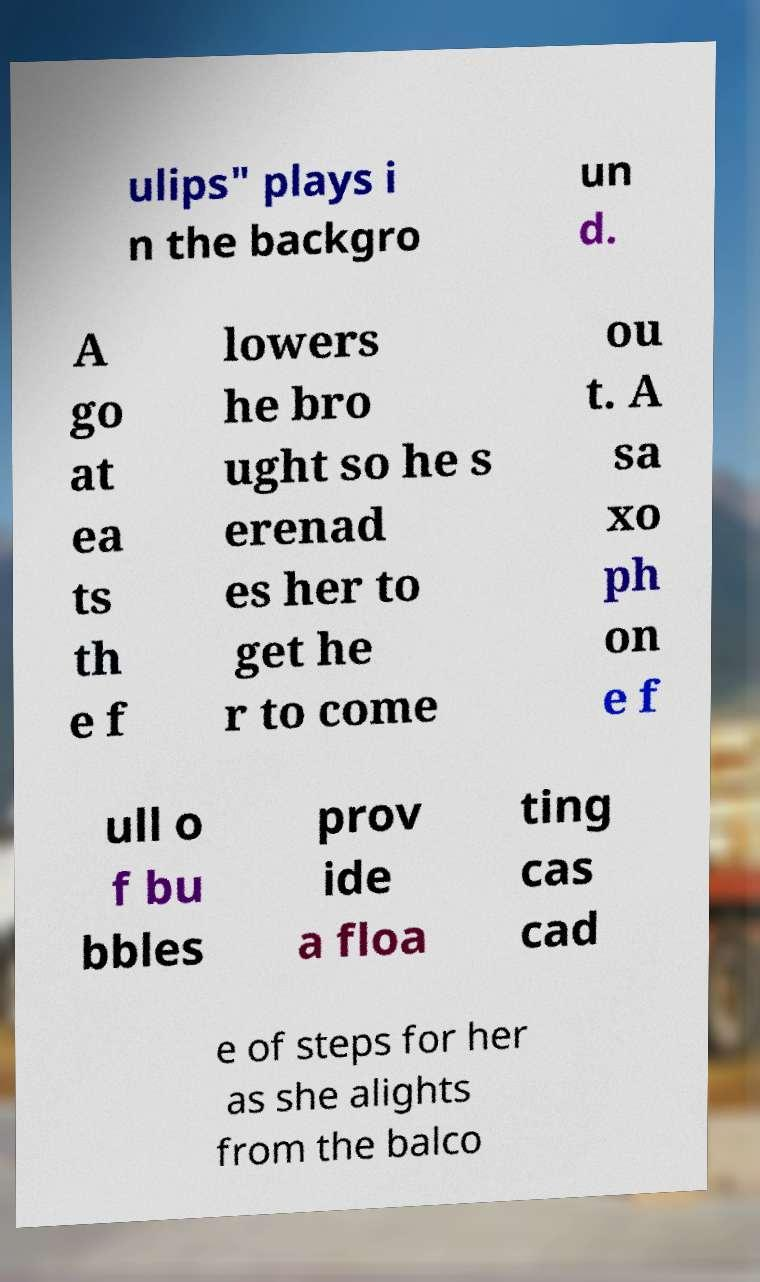Could you assist in decoding the text presented in this image and type it out clearly? ulips" plays i n the backgro un d. A go at ea ts th e f lowers he bro ught so he s erenad es her to get he r to come ou t. A sa xo ph on e f ull o f bu bbles prov ide a floa ting cas cad e of steps for her as she alights from the balco 